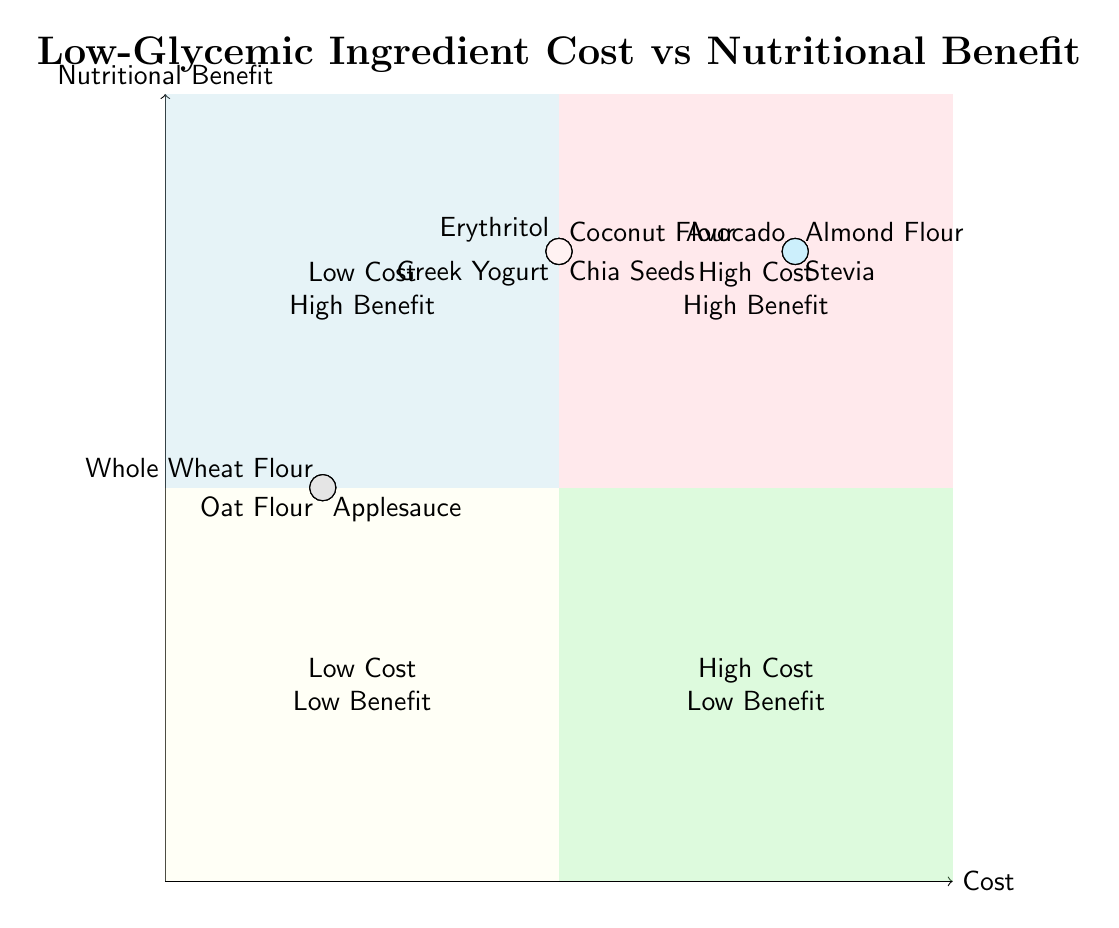What is the cost category for Almond Flour? Almond Flour is plotted in the quadrant where the cost is high and the nutritional benefit is also high. Thus, its cost category is "High".
Answer: High How many ingredients have a low nutritional benefit? In the diagram, the ingredients that fall into the "Low Cost Low Benefit" quadrant have a low nutritional benefit. By reviewing the diagram, we can see there are two ingredients (Whole Wheat Flour and Oat Flour).
Answer: 2 Which ingredient has the highest nutritional benefit but also high cost? The ingredients in the "High Cost High Benefit" quadrant include Almond Flour, Stevia, Greek Yogurt, and Avocado. However, to find the ingredient that specifically has a high nutritional benefit alongside high cost, we look at the ingredients plotted in that quadrant. Both Almond Flour and Avocado have that characteristic, but since the question requests one, we can refer to any of them.
Answer: Almond Flour Is Coconut Flour more affordable than Erythritol? In the diagram, Coconut Flour is located in the "High Benefit Medium Cost" sector, while Erythritol is similarly positioned in terms of benefit but is noted as "Medium" cost. Comparing the two, Coconut Flour has a medium cost as well. Since both are of equal cost levels, they are comparable, yet not more affordable.
Answer: No What quadrant is Avocado located in? Avocado is plotted in the quadrant where cost is high and nutritional benefit is high, which is characterized as "High Cost High Benefit." We identify its location on the chart to respond accurately.
Answer: High Cost High Benefit Which ingredient represents low cost and medium nutritional benefit? The ingredients falling into the "Low Cost Medium Benefit" quadrant, specifically Whole Wheat Flour, Oat Flour, and Applesauce (unsweetened), all share the descriptions of low cost and medium nutritional benefit. Thus, they represent this characteristic.
Answer: Whole Wheat Flour, Oat Flour, Applesauce How many ingredients are there in the High Cost Low Benefit quadrant? Looking at the diagram, we can observe that there are no ingredients plotted in the "High Cost Low Benefit" quadrant, as it is empty according to the representation. Thus, the answer will reflect that.
Answer: 0 Which ingredient has a cost category that is medium but a high nutritional benefit? Ingredients located in the quadrant for "Medium Cost High Benefit" include Coconut Flour, Chia Seeds, Erythritol, and Greek Yogurt. Each of these has a medium cost but high nutritional benefit.
Answer: Coconut Flour What is the lowest nutritional benefit among the represented ingredients? By reviewing the chart, we find that the lowest nutritional benefit displayed is "Medium," which applies to the ingredients represented in the "Low Cost Medium Benefit" quadrant. Thus, we conclude this is the minimum.
Answer: Medium 